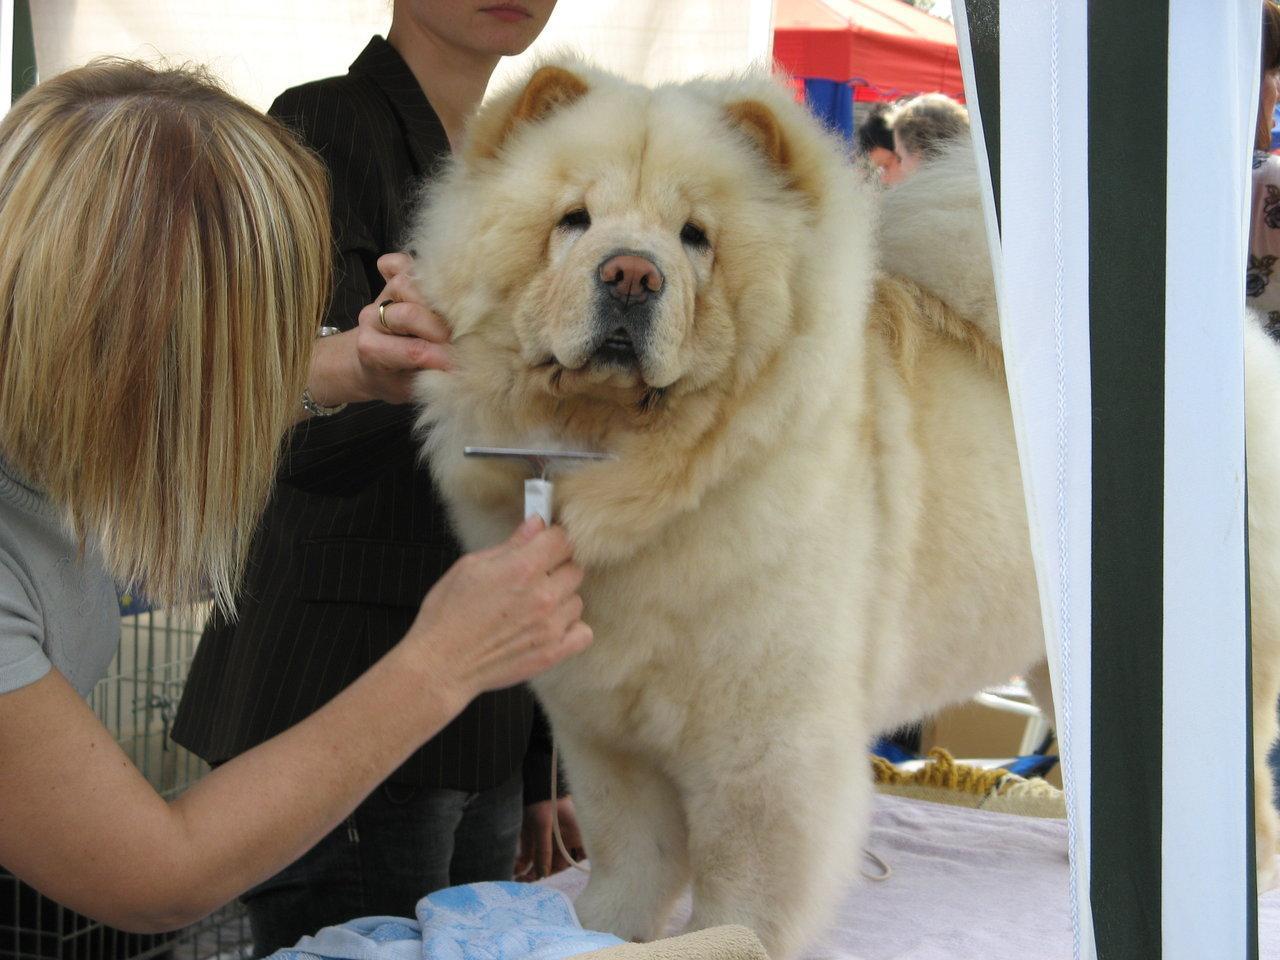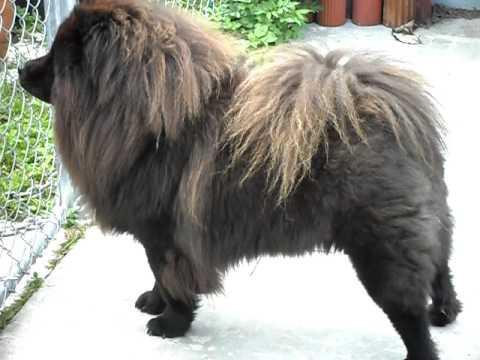The first image is the image on the left, the second image is the image on the right. Examine the images to the left and right. Is the description "At least one human is interacting with at least one dog, in one of the images." accurate? Answer yes or no. Yes. 